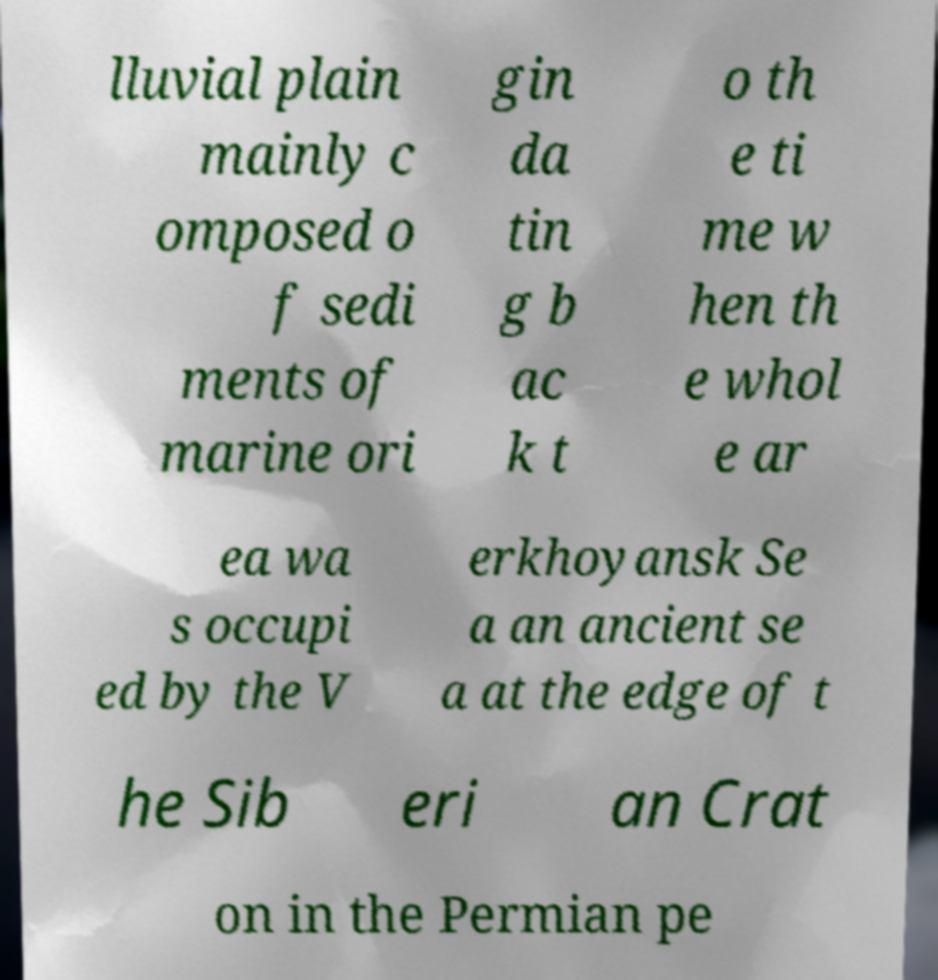Could you extract and type out the text from this image? lluvial plain mainly c omposed o f sedi ments of marine ori gin da tin g b ac k t o th e ti me w hen th e whol e ar ea wa s occupi ed by the V erkhoyansk Se a an ancient se a at the edge of t he Sib eri an Crat on in the Permian pe 